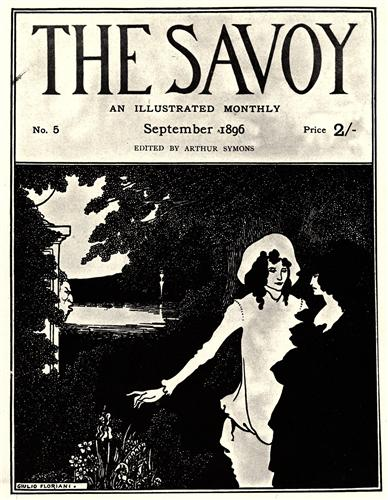If this image were to come to life, what kind of sounds and scents would fill the air? If this image were to come to life, the air would be filled with the soft rustling of leaves as a gentle breeze swept through the garden. The melodic sound of birds chirping harmoniously and the gentle babble of the river flowing in the background would provide a soothing auditory backdrop. Occasionally, the air would carry the sweet, delicate scent of blooming flowers, mingled with the earthy fragrance of the moist soil and the crisp, fresh aroma of the surrounding greenery. A sense of calm and tranquility would envelop anyone present, making it a haven of natural beauty. 